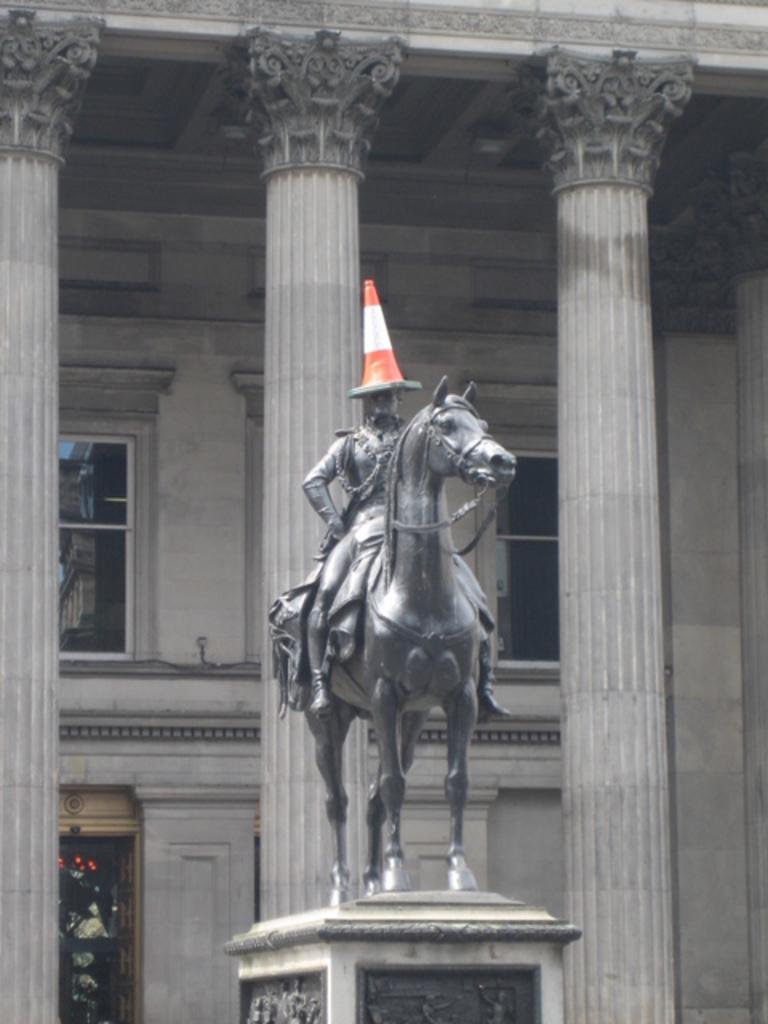What is the main subject in the center of the image? There is a statue in the center of the image. What can be seen in the background of the image? There is a building and pillars in the background of the image. How many feet are visible on the statue in the image? The image does not show any feet on the statue, as it only depicts the statue from the waist up. 